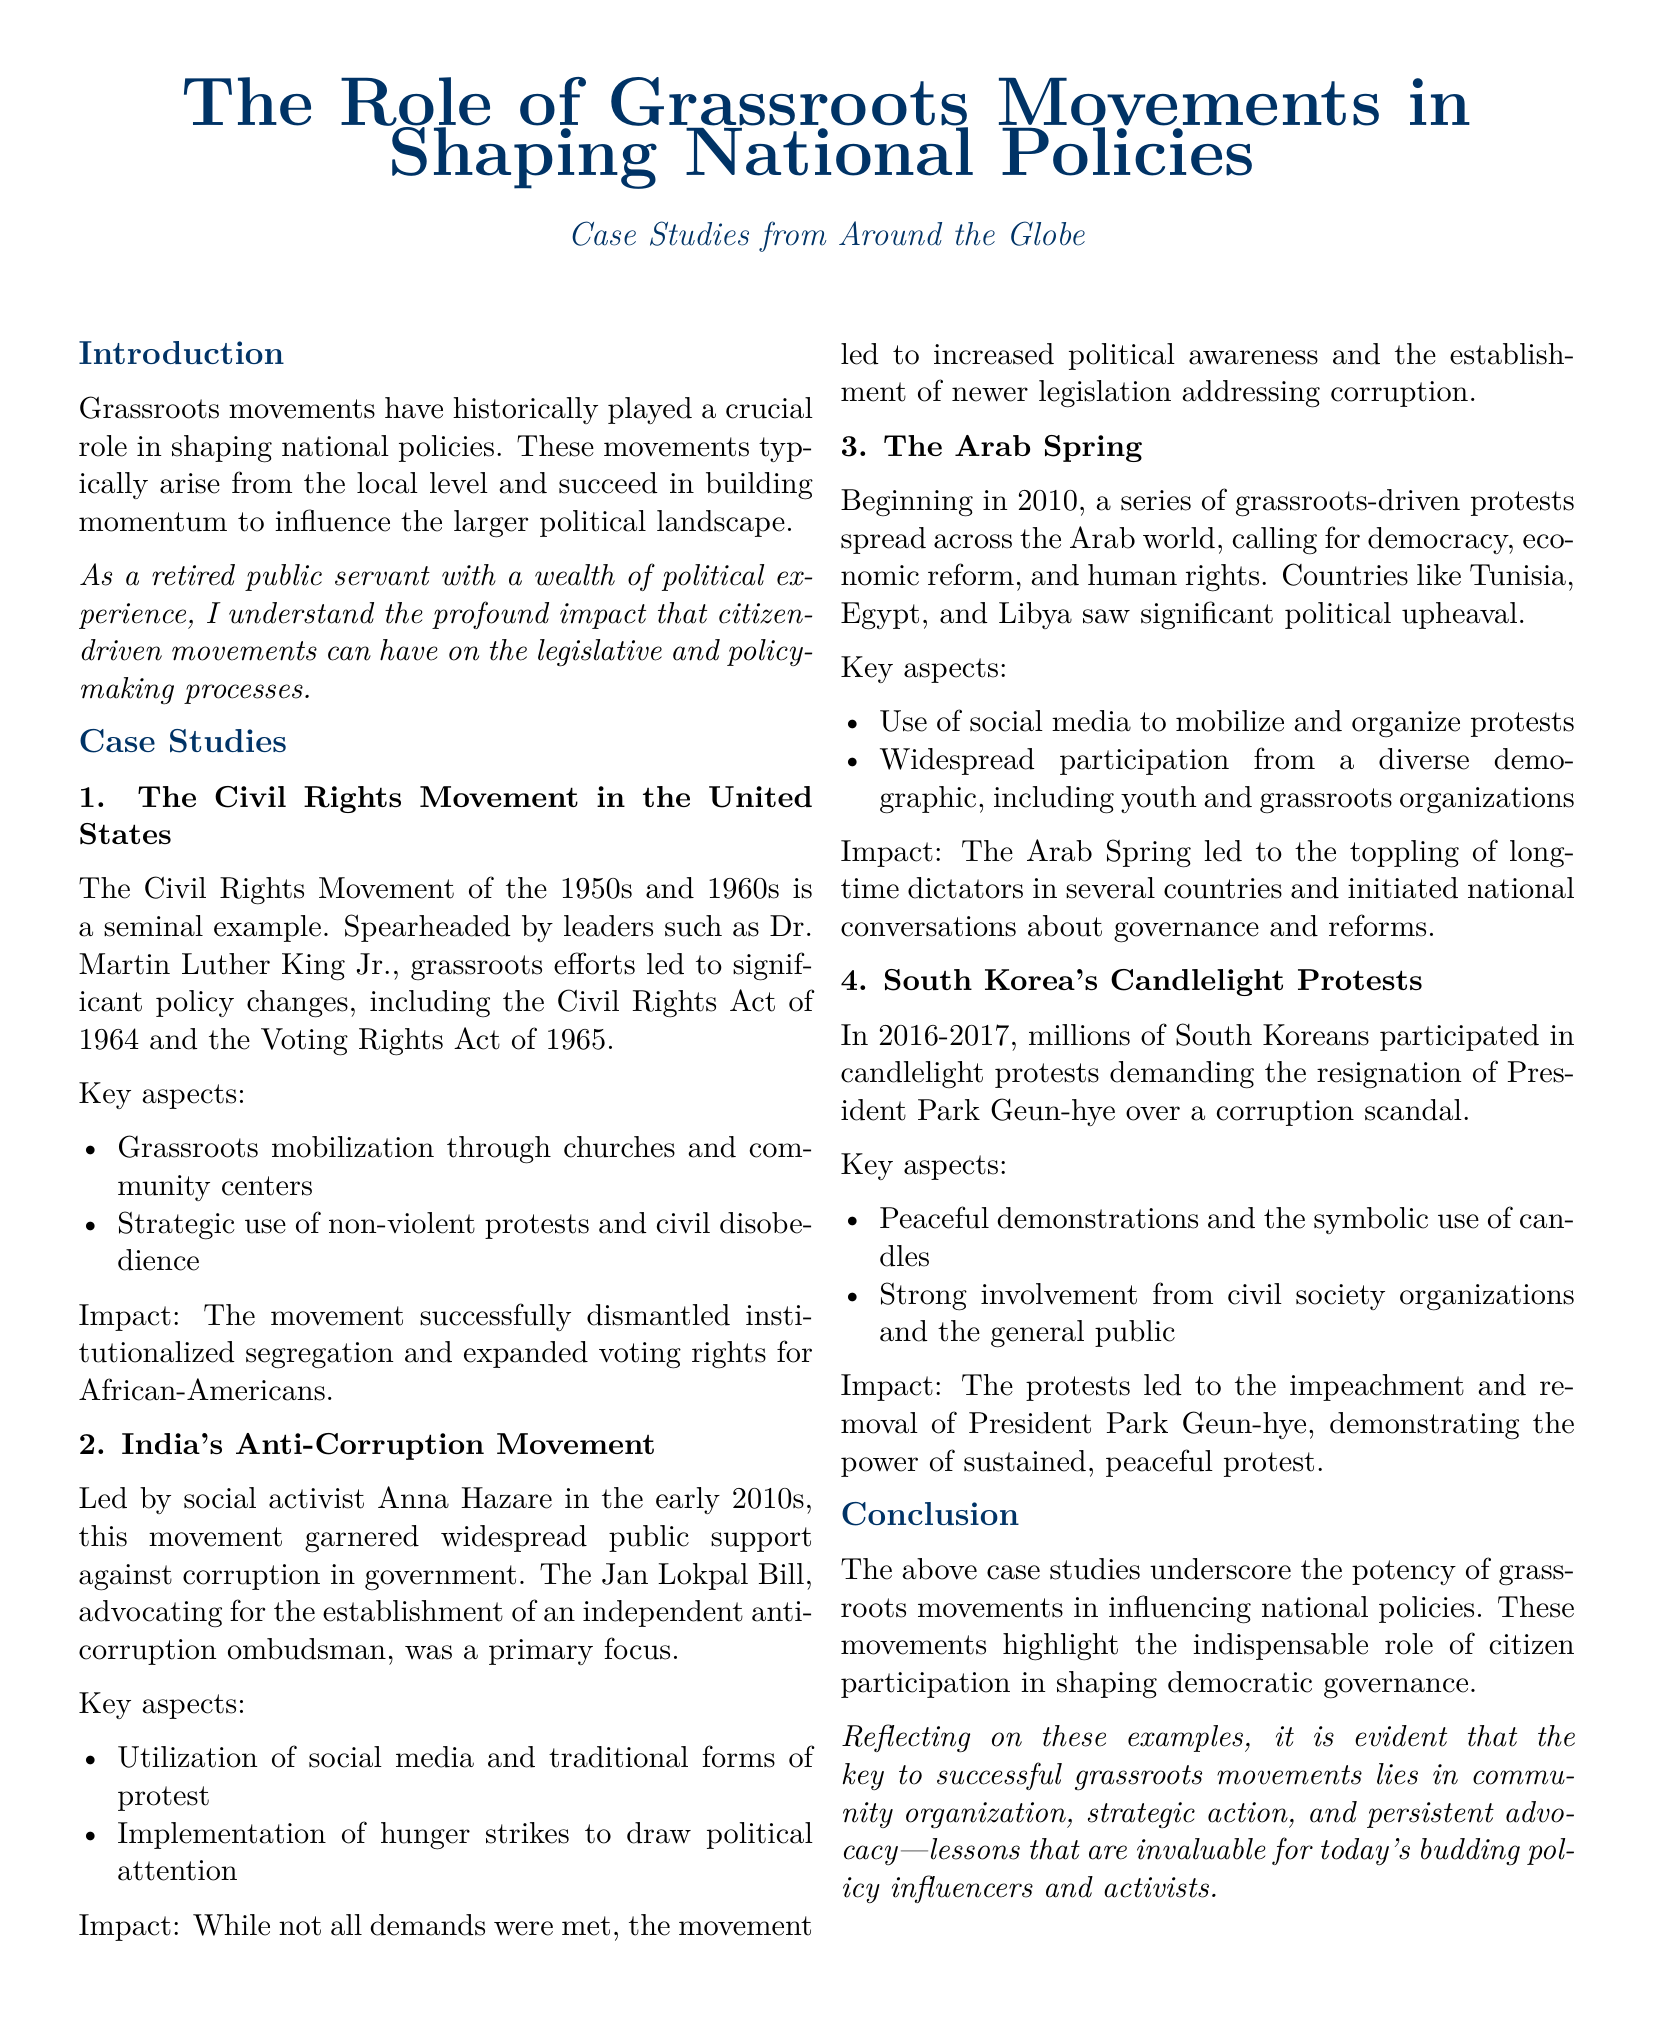What is the main topic of the whitepaper? The main topic is about grassroots movements and their impact on national policies as discussed in various case studies.
Answer: The Role of Grassroots Movements in Shaping National Policies Who is a prominent leader associated with the Civil Rights Movement? The document identifies Dr. Martin Luther King Jr. as a key figure in the Civil Rights Movement.
Answer: Dr. Martin Luther King Jr What legislative act is linked to the Civil Rights Movement? The document mentions the Civil Rights Act of 1964 as a significant outcome of the movement.
Answer: Civil Rights Act of 1964 Which country’s protest movement is associated with Anna Hazare? The document references India's Anti-Corruption Movement led by Anna Hazare.
Answer: India In which year did the Arab Spring begin? The document states that the Arab Spring began in 2010.
Answer: 2010 What was a key strategy used during South Korea's Candlelight Protests? The protests were characterized by peaceful demonstrations and the use of candles as a symbol.
Answer: Peaceful demonstrations What role did social media play in the Arab Spring? Social media was utilized to mobilize and organize protests during the Arab Spring.
Answer: Mobilize and organize protests What is emphasized as vital for successful grassroots movements? The document highlights community organization, strategic action, and persistent advocacy.
Answer: Community organization, strategic action, and persistent advocacy 